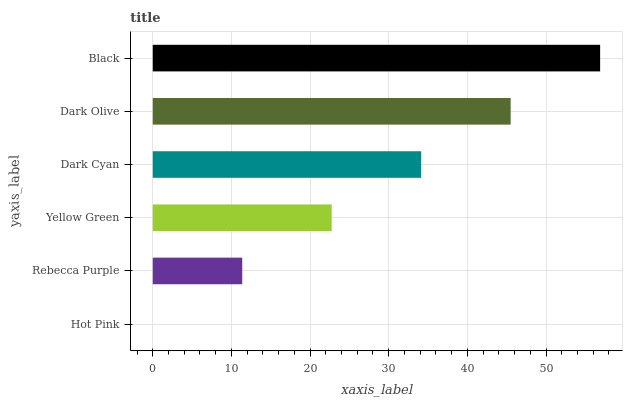Is Hot Pink the minimum?
Answer yes or no. Yes. Is Black the maximum?
Answer yes or no. Yes. Is Rebecca Purple the minimum?
Answer yes or no. No. Is Rebecca Purple the maximum?
Answer yes or no. No. Is Rebecca Purple greater than Hot Pink?
Answer yes or no. Yes. Is Hot Pink less than Rebecca Purple?
Answer yes or no. Yes. Is Hot Pink greater than Rebecca Purple?
Answer yes or no. No. Is Rebecca Purple less than Hot Pink?
Answer yes or no. No. Is Dark Cyan the high median?
Answer yes or no. Yes. Is Yellow Green the low median?
Answer yes or no. Yes. Is Black the high median?
Answer yes or no. No. Is Black the low median?
Answer yes or no. No. 